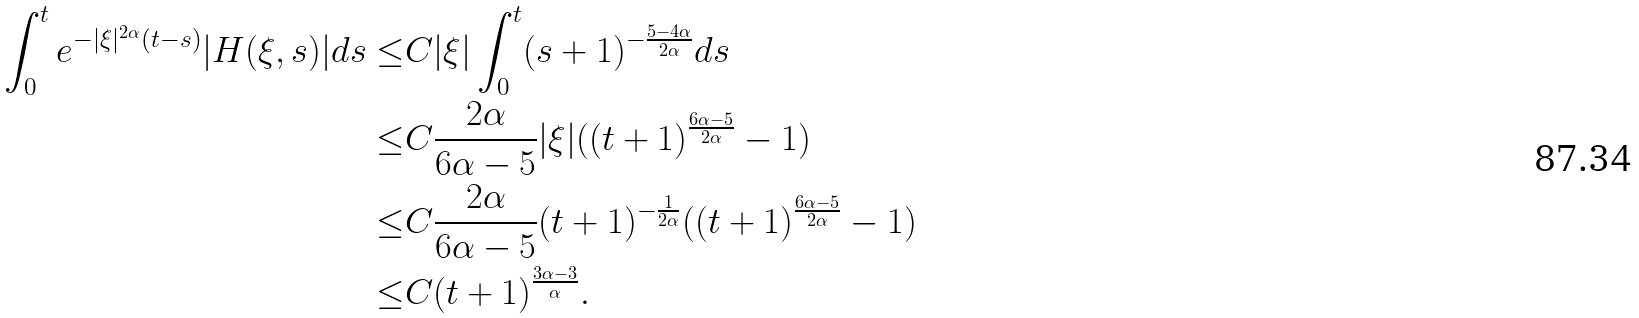<formula> <loc_0><loc_0><loc_500><loc_500>\int _ { 0 } ^ { t } e ^ { - | \xi | ^ { 2 \alpha } ( t - s ) } | H ( \xi , s ) | d s \leq & C | \xi | \int _ { 0 } ^ { t } ( s + 1 ) ^ { - \frac { 5 - 4 \alpha } { 2 \alpha } } d s \\ \leq & C \frac { 2 \alpha } { 6 \alpha - 5 } | \xi | ( ( t + 1 ) ^ { \frac { 6 \alpha - 5 } { 2 \alpha } } - 1 ) \\ \leq & C \frac { 2 \alpha } { 6 \alpha - 5 } ( t + 1 ) ^ { - \frac { 1 } { 2 \alpha } } ( ( t + 1 ) ^ { \frac { 6 \alpha - 5 } { 2 \alpha } } - 1 ) \\ \leq & C ( t + 1 ) ^ { \frac { 3 \alpha - 3 } { \alpha } } .</formula> 